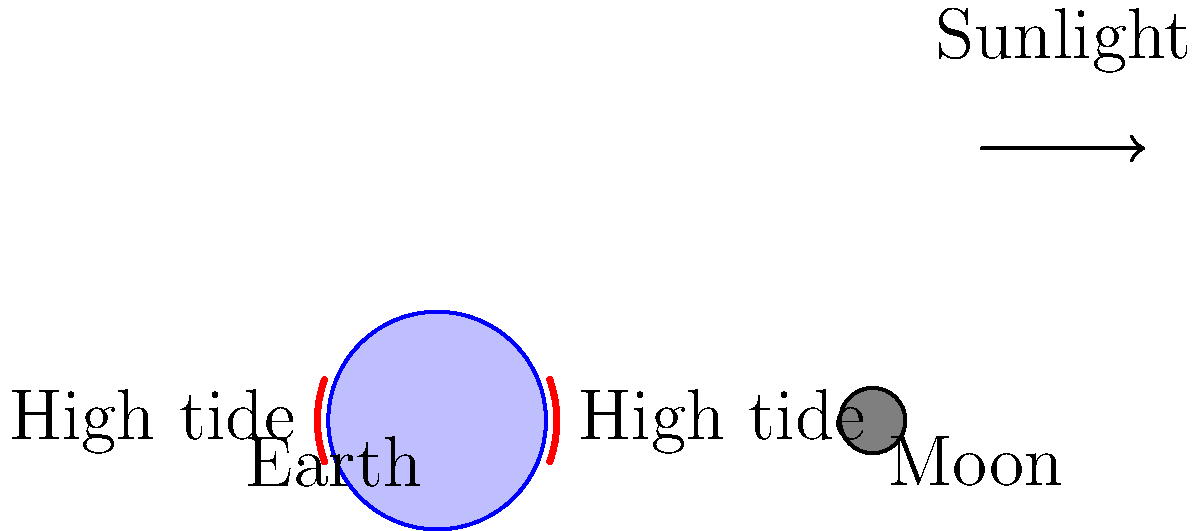Based on the diagram of the Earth-Moon system, which statement about the relationship between the moon's phases and tidal patterns is most accurate, and why might this conclusion be met with skepticism? To answer this question, let's analyze the diagram and consider the relationship between the moon's phases and tidal patterns:

1. The diagram shows the Earth-Moon system with the direction of sunlight indicated.

2. We can see that the moon is positioned on the right side of the Earth, which corresponds to either a full moon or a new moon phase, depending on the exact alignment with the Sun.

3. The red arcs on the Earth represent high tides, which are shown on both the side facing the moon and the opposite side.

4. This tidal pattern is consistent with the gravitational pull of the moon, which causes bulges in the Earth's oceans on both the near and far sides.

5. The strongest tidal effects (spring tides) occur during full and new moon phases when the Sun, Moon, and Earth are aligned.

6. However, the diagram doesn't show how tidal patterns change throughout the lunar cycle, which might lead to skepticism about the full relationship.

7. A skeptical person might question:
   a) Whether this pattern holds true for all locations on Earth
   b) How other factors like Earth's rotation or local geography affect tides
   c) The precise timing of tides in relation to the moon's position

8. The most accurate statement would be: "The moon's gravitational pull creates two high tides daily, with the strongest tides occurring during full and new moon phases."

This conclusion might be met with skepticism because it simplifies a complex system and doesn't account for all variables affecting tidal patterns.
Answer: Strongest tides occur during full and new moon phases, but this simplification may not account for all factors affecting tidal patterns. 